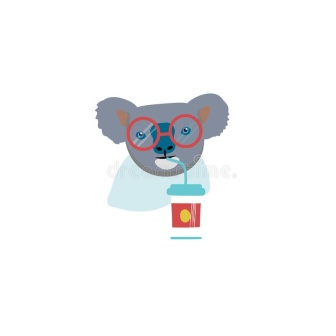How does the choice of colors used in the koala's glasses and drink contribute to the overall mood of the image? The use of vibrant red for the glasses and the cup, paired with yellow accents, injects a dynamic and spirited energy into the image. These colors are often associated with excitement and happiness, which complements the playful nature of the koala. The color scheme effectively enhances the whimsical and joyful mood of the scene, making the image more appealing and lively. 